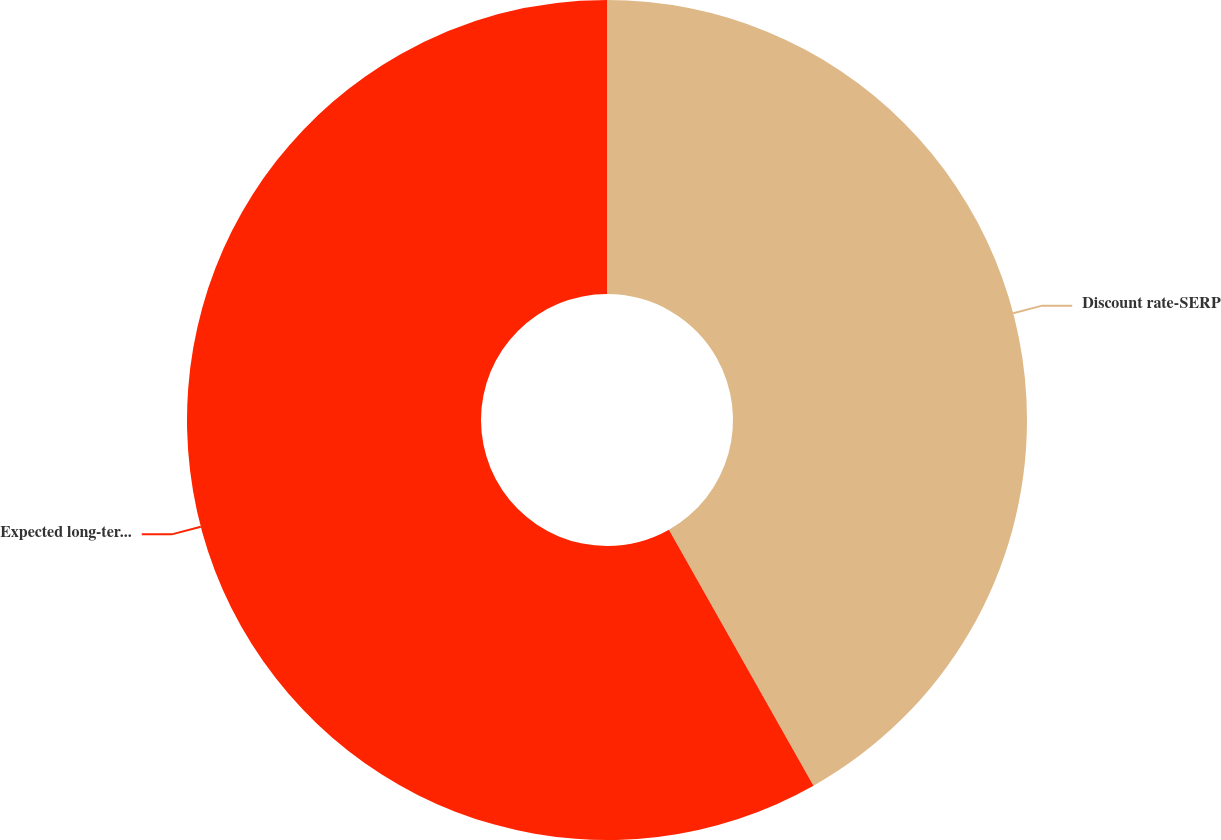<chart> <loc_0><loc_0><loc_500><loc_500><pie_chart><fcel>Discount rate-SERP<fcel>Expected long-term rate of<nl><fcel>41.82%<fcel>58.18%<nl></chart> 